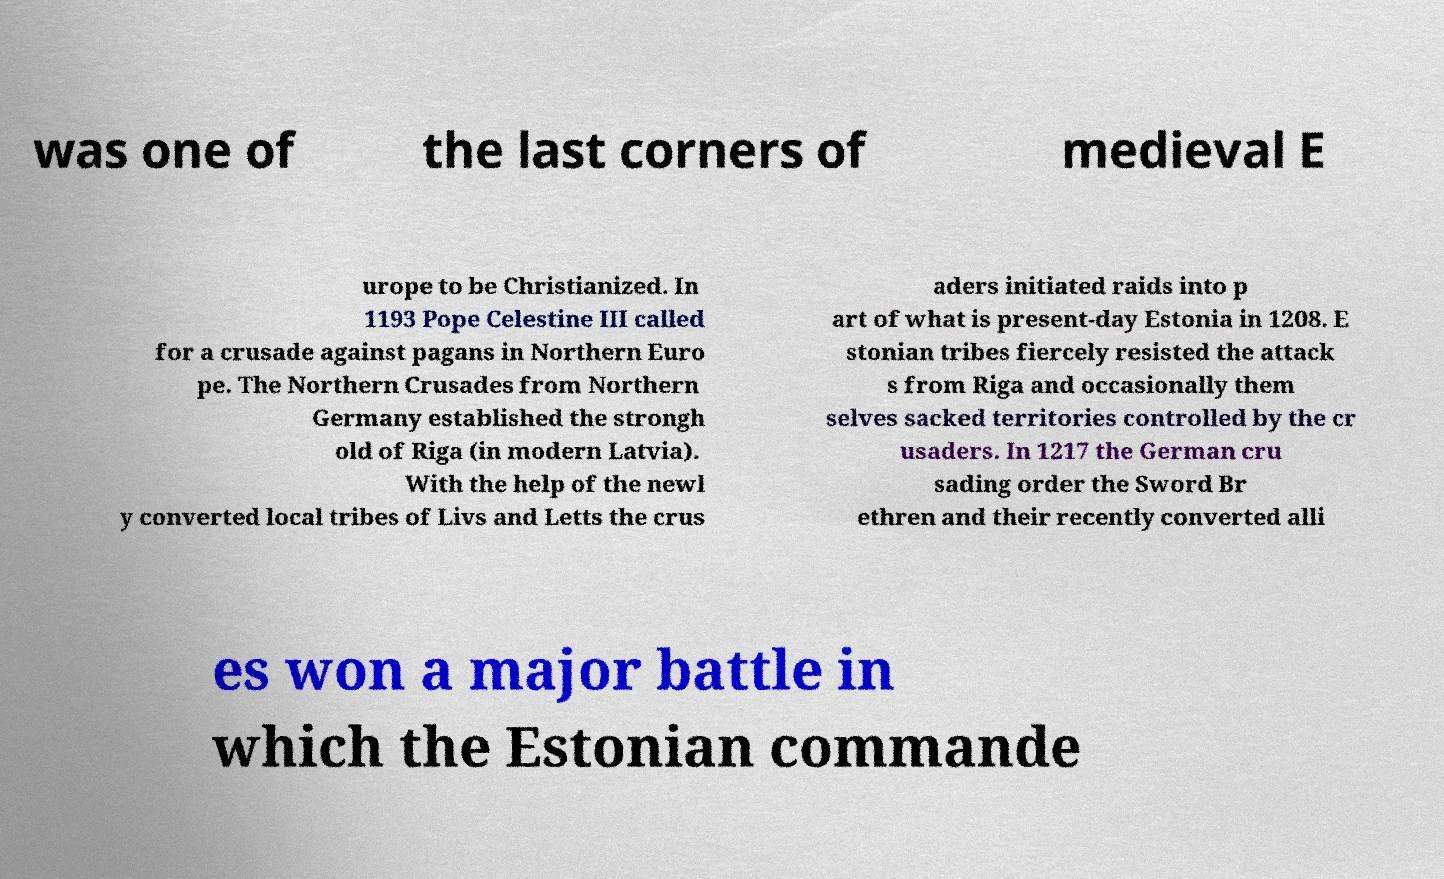Could you extract and type out the text from this image? was one of the last corners of medieval E urope to be Christianized. In 1193 Pope Celestine III called for a crusade against pagans in Northern Euro pe. The Northern Crusades from Northern Germany established the strongh old of Riga (in modern Latvia). With the help of the newl y converted local tribes of Livs and Letts the crus aders initiated raids into p art of what is present-day Estonia in 1208. E stonian tribes fiercely resisted the attack s from Riga and occasionally them selves sacked territories controlled by the cr usaders. In 1217 the German cru sading order the Sword Br ethren and their recently converted alli es won a major battle in which the Estonian commande 